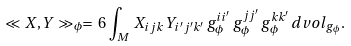Convert formula to latex. <formula><loc_0><loc_0><loc_500><loc_500>\ll X , Y \gg _ { \phi } = \, 6 \, \int _ { M } \, X _ { i j k } \, Y _ { i ^ { \prime } j ^ { \prime } k ^ { \prime } } \, g _ { \phi } ^ { i i ^ { \prime } } \, g _ { \phi } ^ { j j ^ { \prime } } \, g _ { \phi } ^ { k k ^ { \prime } } \, d v o l _ { g _ { \phi } } .</formula> 